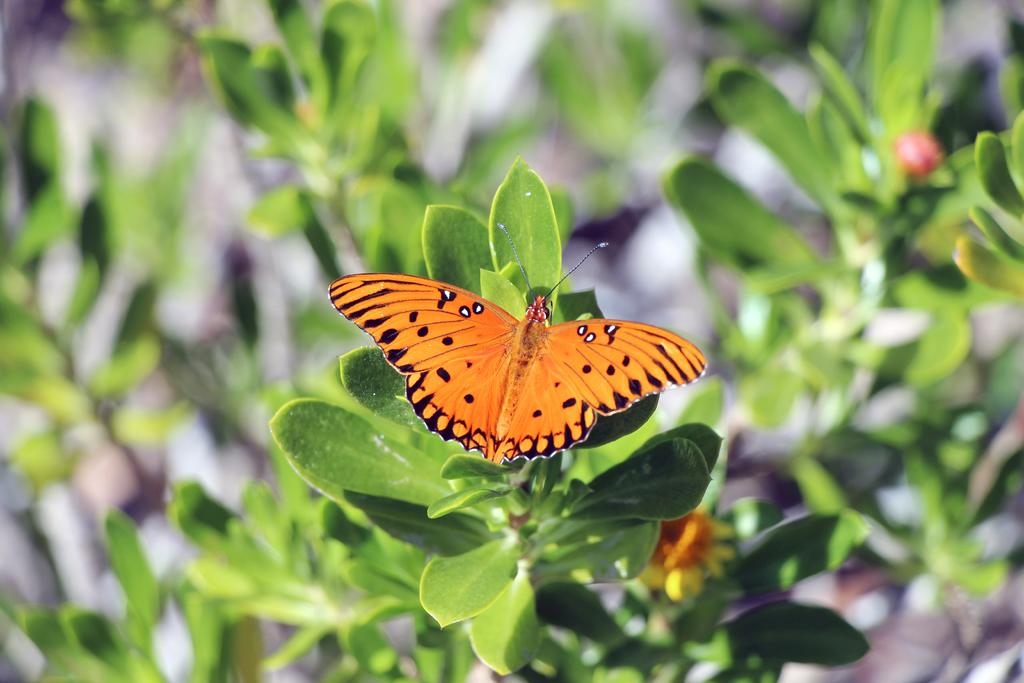What is the main subject of the image? There is a butterfly in the image. Where is the butterfly located? The butterfly is on a plant. What colors can be seen on the butterfly? The butterfly has brown and black colors. What type of vegetation is present in the image? There are plants in the image. What color are the plants? The plants have green colors. What religious symbol can be seen on the butterfly in the image? There is no religious symbol present on the butterfly in the image. 